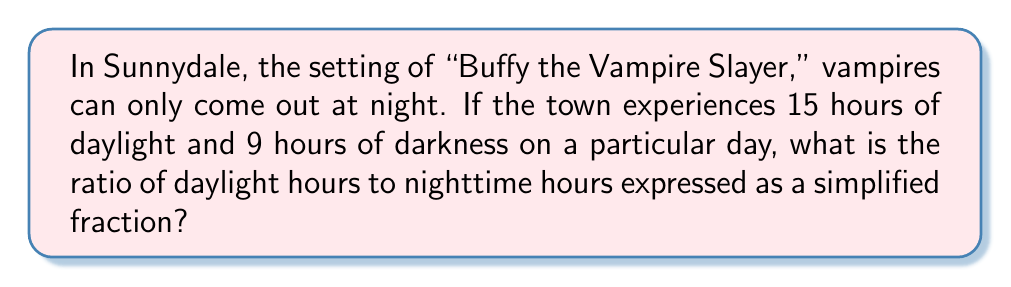Show me your answer to this math problem. Let's approach this step-by-step:

1) We're given that there are 15 hours of daylight and 9 hours of darkness.

2) To find the ratio, we compare these two values:
   
   Daylight hours : Nighttime hours = 15 : 9

3) This ratio can be simplified by dividing both numbers by their greatest common divisor (GCD).

4) To find the GCD of 15 and 9:
   Factors of 15: 1, 3, 5, 15
   Factors of 9: 1, 3, 9
   The greatest common factor is 3.

5) Divide both numbers by 3:
   
   $\frac{15}{3} : \frac{9}{3} = 5 : 3$

Therefore, the simplified ratio of daylight hours to nighttime hours is 5:3.

In fraction form, this can be written as $\frac{5}{3}$.
Answer: $\frac{5}{3}$ 